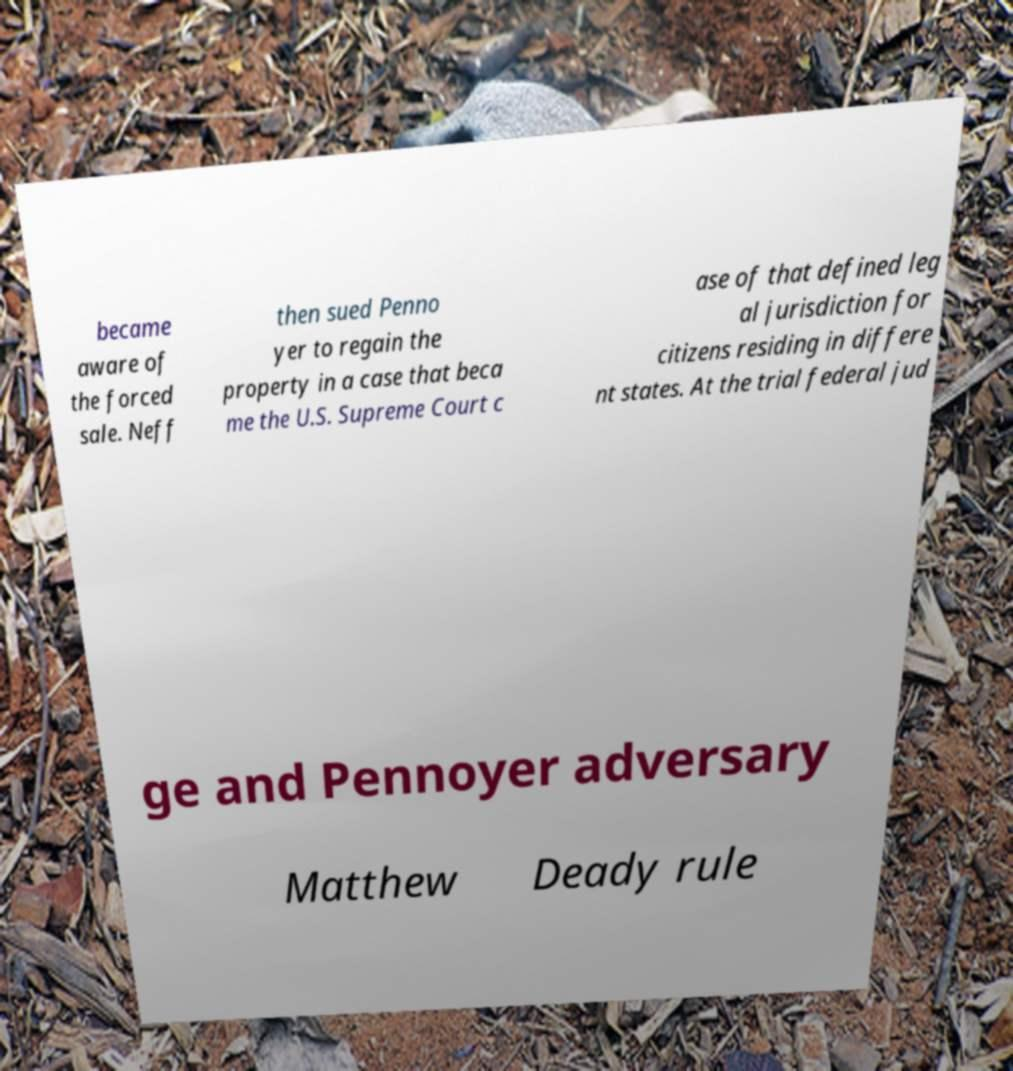Can you read and provide the text displayed in the image?This photo seems to have some interesting text. Can you extract and type it out for me? became aware of the forced sale. Neff then sued Penno yer to regain the property in a case that beca me the U.S. Supreme Court c ase of that defined leg al jurisdiction for citizens residing in differe nt states. At the trial federal jud ge and Pennoyer adversary Matthew Deady rule 